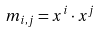<formula> <loc_0><loc_0><loc_500><loc_500>m _ { i , j } = x ^ { i } \cdot x ^ { j }</formula> 